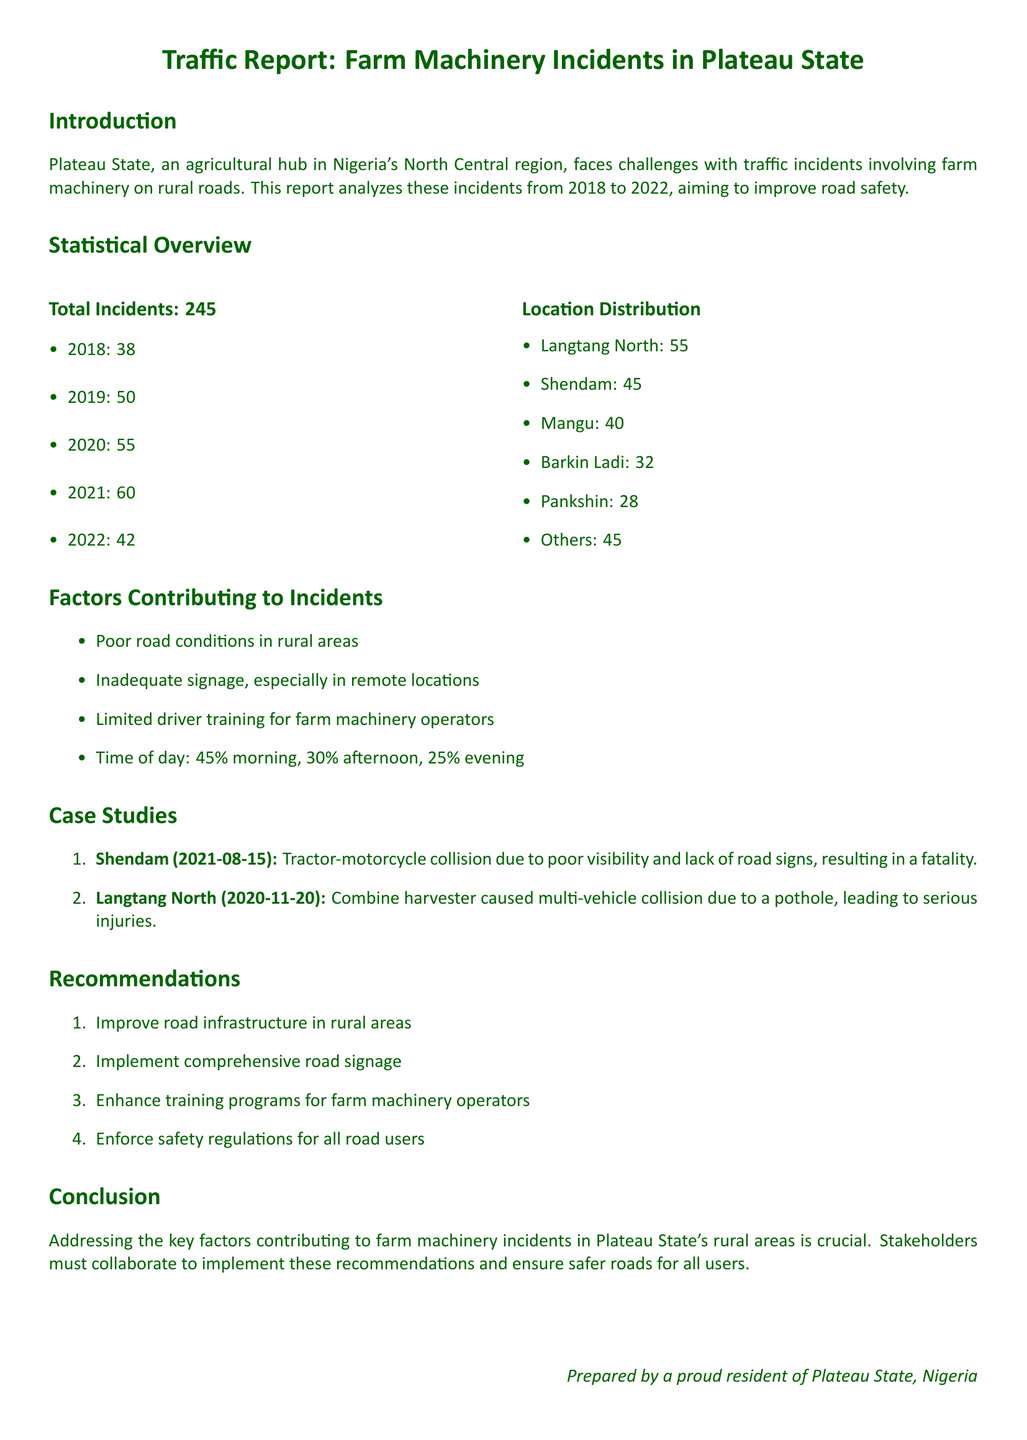what is the total number of traffic incidents? The document states there were 245 total incidents involving farm machinery from 2018 to 2022.
Answer: 245 which year had the highest number of incidents? From the statistical overview, 2021 had the highest count of incidents at 60.
Answer: 2021 how many incidents occurred in Langtang North? According to the location distribution, Langtang North reported 55 incidents.
Answer: 55 what percentage of incidents occurred in the morning? The report indicates that 45% of incidents happened in the morning.
Answer: 45% what were the two case study locations mentioned? The case studies include incidents from Shendam and Langtang North.
Answer: Shendam, Langtang North what is a key recommendation made in the report? The document recommends improving road infrastructure in rural areas as a solution.
Answer: Improve road infrastructure how many incidents were reported in 2020? The report shows that there were 55 incidents in 2020.
Answer: 55 what is a contributing factor to traffic incidents? The report mentions poor road conditions as a contributing factor.
Answer: Poor road conditions how many incidents occurred in Pankshin? According to the location distribution, Pankshin experienced 28 incidents.
Answer: 28 